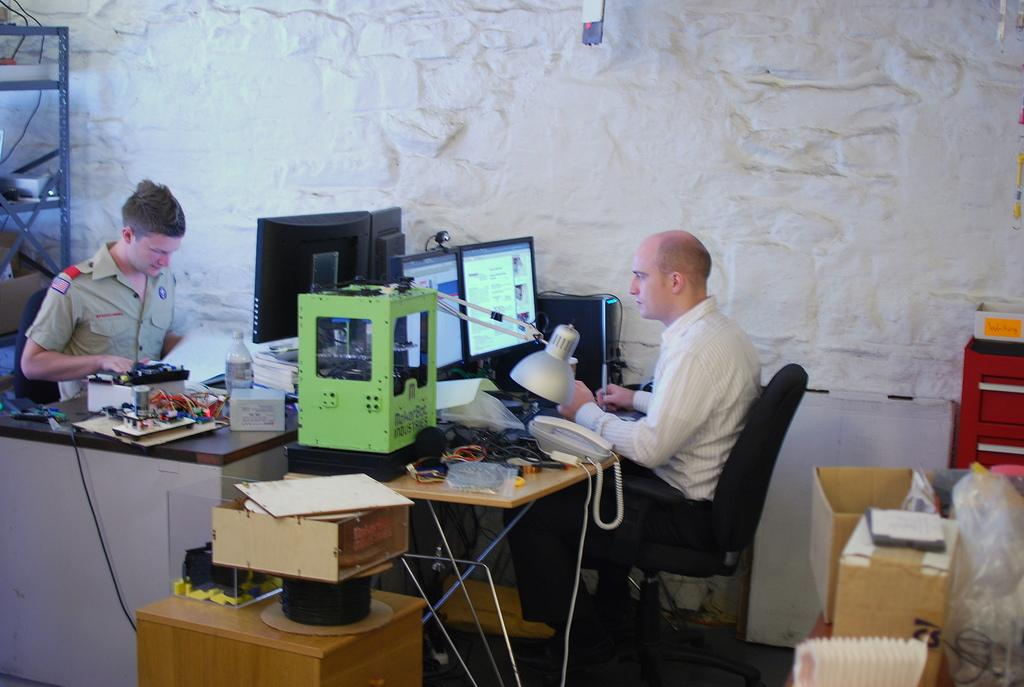How many people are present in the image? There are two people in the image. What are the people doing in the image? Both people are looking at systems. What else can be seen in the image besides the people? There are books and electrical stuff on the tables. What type of fly can be seen buzzing around the vase in the image? There is no fly or vase present in the image. 